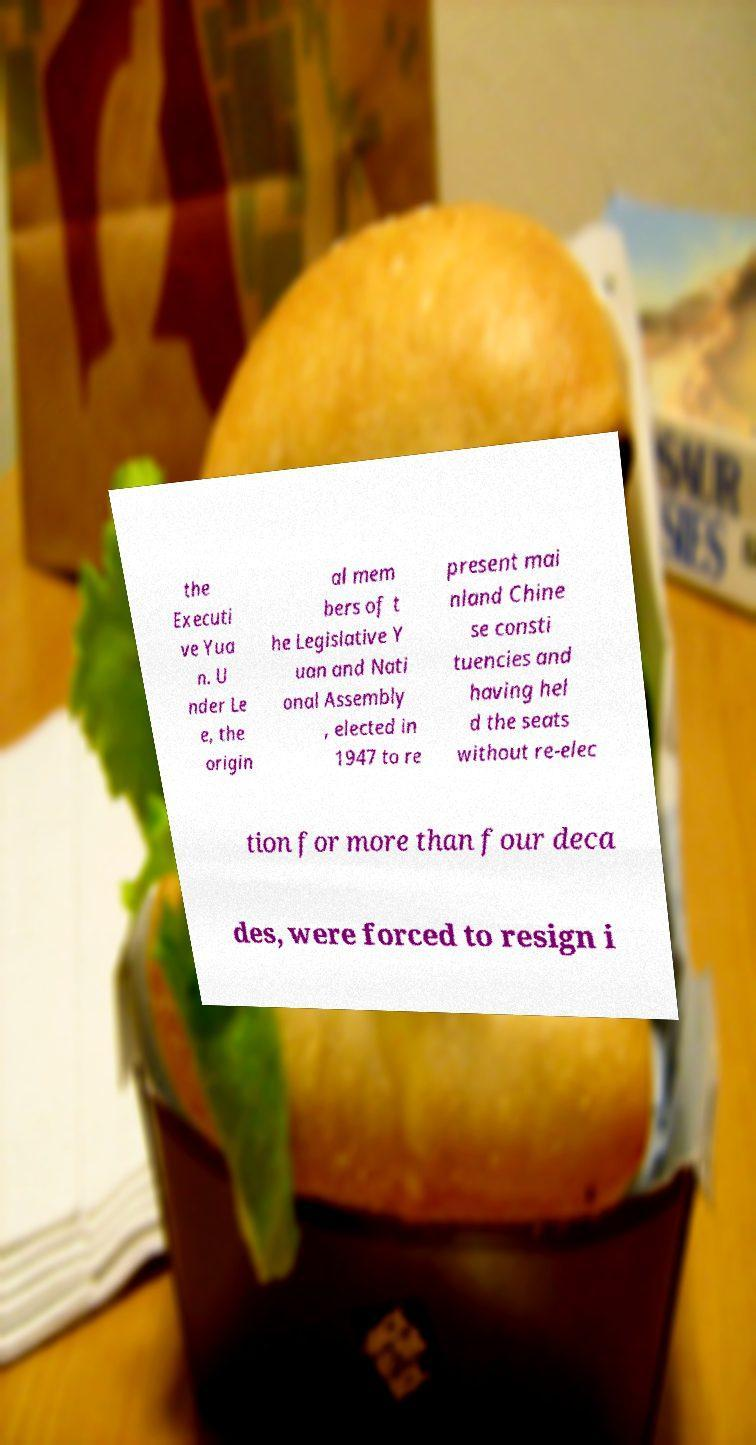Can you read and provide the text displayed in the image?This photo seems to have some interesting text. Can you extract and type it out for me? the Executi ve Yua n. U nder Le e, the origin al mem bers of t he Legislative Y uan and Nati onal Assembly , elected in 1947 to re present mai nland Chine se consti tuencies and having hel d the seats without re-elec tion for more than four deca des, were forced to resign i 